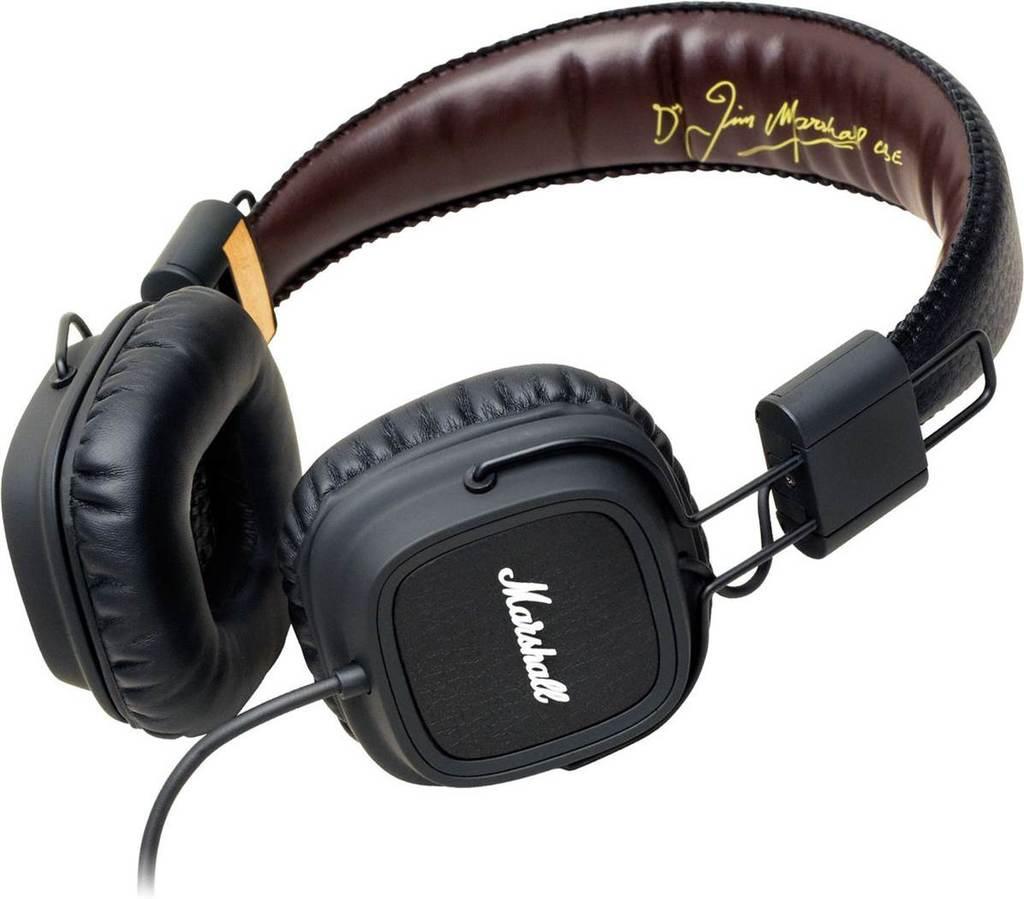Describe this image in one or two sentences. In this picture we can see headphones and in the background we can see white color. 